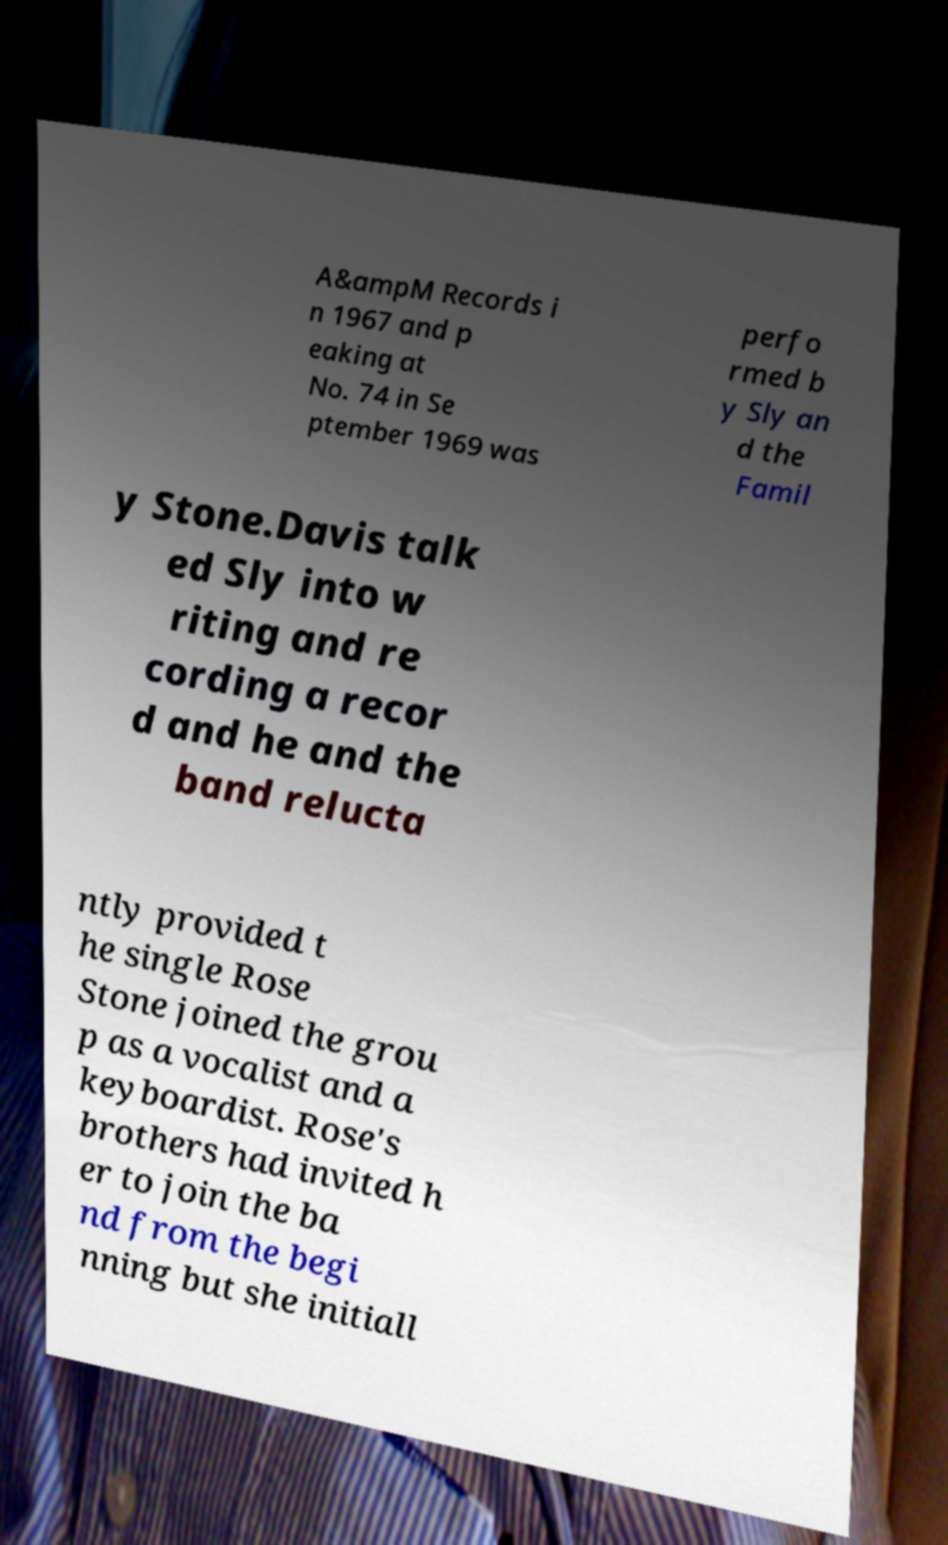Can you accurately transcribe the text from the provided image for me? A&ampM Records i n 1967 and p eaking at No. 74 in Se ptember 1969 was perfo rmed b y Sly an d the Famil y Stone.Davis talk ed Sly into w riting and re cording a recor d and he and the band relucta ntly provided t he single Rose Stone joined the grou p as a vocalist and a keyboardist. Rose's brothers had invited h er to join the ba nd from the begi nning but she initiall 